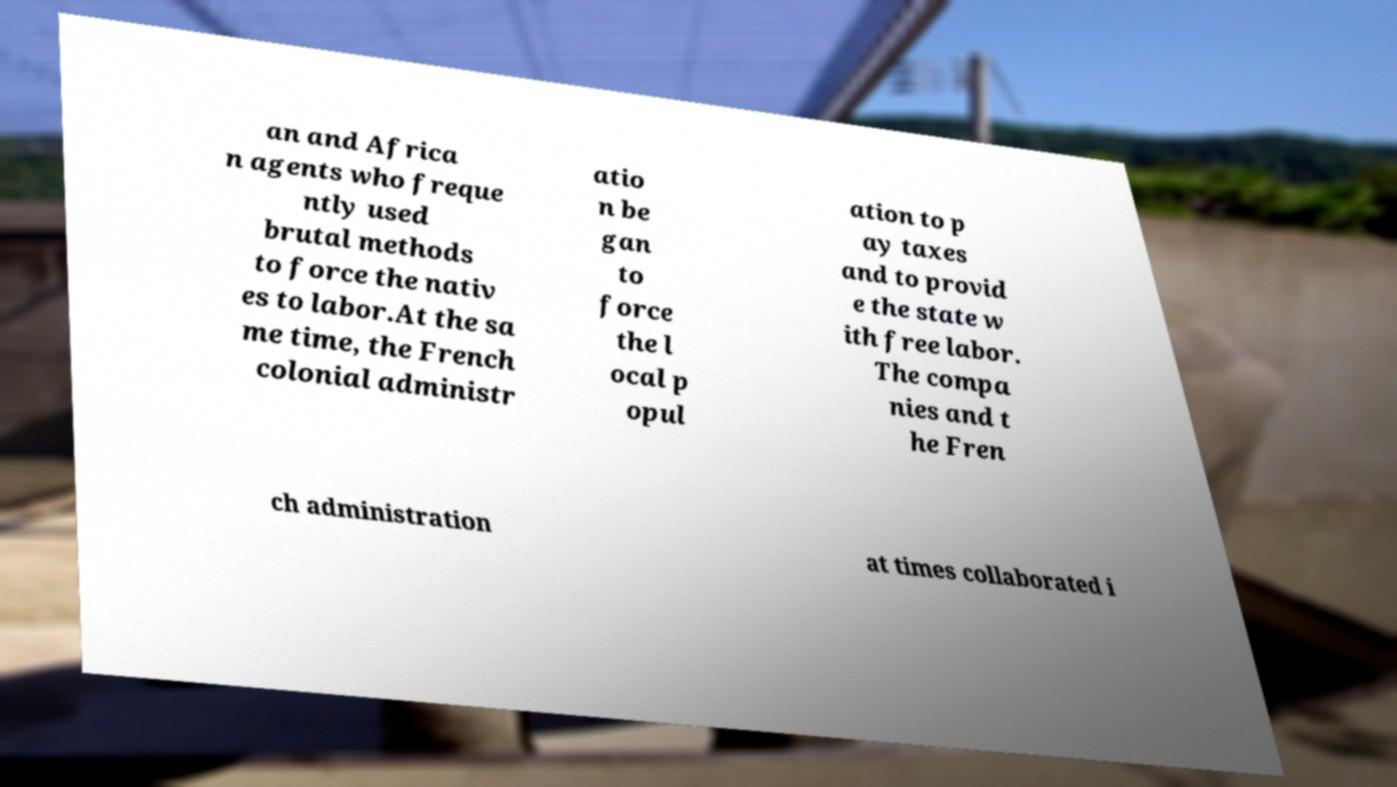Can you read and provide the text displayed in the image?This photo seems to have some interesting text. Can you extract and type it out for me? an and Africa n agents who freque ntly used brutal methods to force the nativ es to labor.At the sa me time, the French colonial administr atio n be gan to force the l ocal p opul ation to p ay taxes and to provid e the state w ith free labor. The compa nies and t he Fren ch administration at times collaborated i 